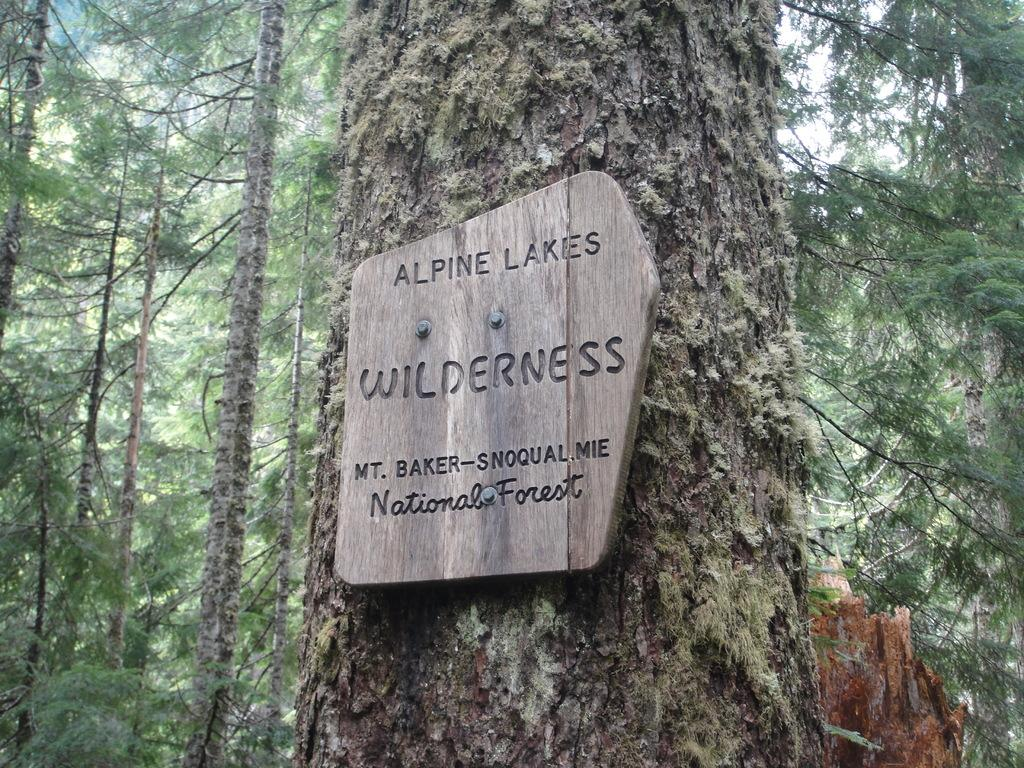What is the main object in the foreground of the image? There is a tree in the front of the image. What is attached to the tree in the image? A wooden name board is mounted on the tree. What can be seen in the background of the image? Many trees are visible in the background of the image. What type of whip is hanging from the tree in the image? There is no whip present in the image; it features a tree with a wooden name board mounted on it. How many quinces are visible on the tree in the image? There are no quinces visible on the tree in the image; it is a tree with a wooden name board mounted on it. 